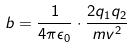Convert formula to latex. <formula><loc_0><loc_0><loc_500><loc_500>b = \frac { 1 } { 4 \pi \epsilon _ { 0 } } \cdot \frac { 2 q _ { 1 } q _ { 2 } } { m v ^ { 2 } }</formula> 